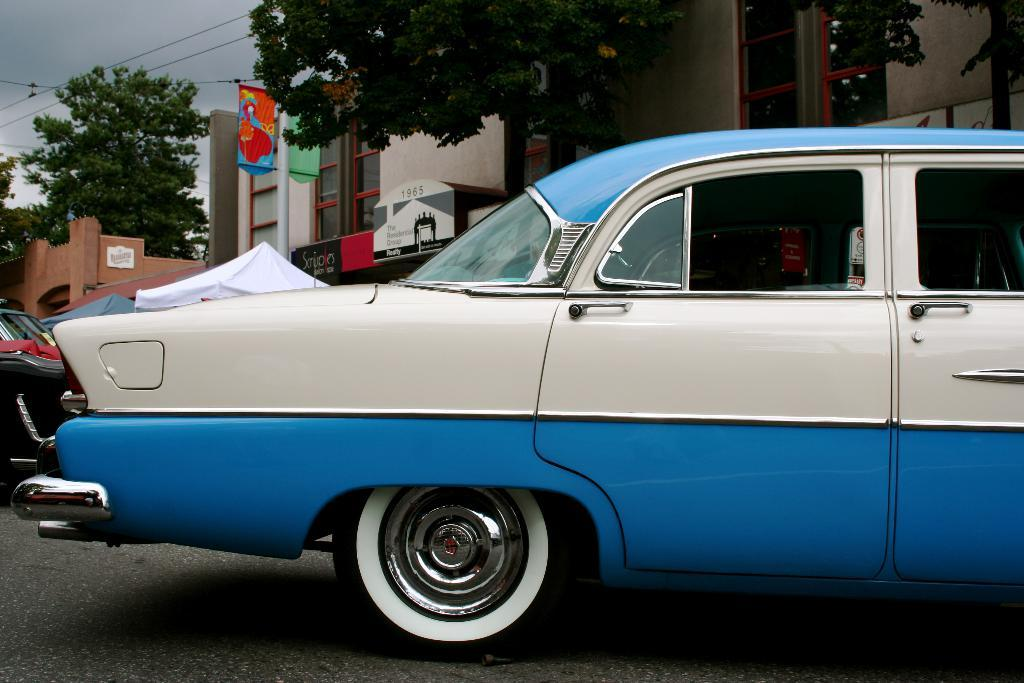What types of man-made structures can be seen in the image? There are buildings in the image. What else can be seen in the image besides buildings? There are vehicles, boards, and trees visible in the image. What is the natural element present in the image? Trees are the natural element present in the image. What can be seen in the background of the image? The sky is visible in the background of the image. How many balls are being used to create the curve in the image? There are no balls or curves present in the image. What type of burn can be seen on the vehicles in the image? There are no burns visible on the vehicles in the image. 